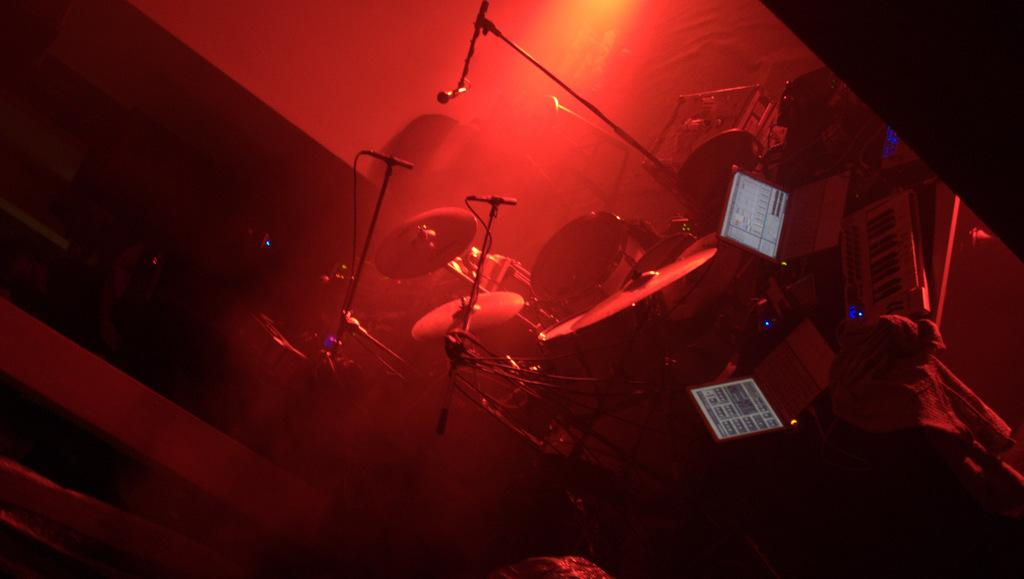What musical instruments are in the middle of the image? There are drums and a keyboard in the middle of the image. What electronic device is in the middle of the image? There is a laptop in the middle of the image. What is used for amplifying sound in the image? There is a microphone in the middle of the image. What can be seen behind the instruments in the image? There is a wall behind the instruments in the image. What type of question is being asked in the image? There is no question being asked in the image; it features musical instruments, a keyboard, a microphone, a laptop, and a wall. What is the source of steam in the image? There is no steam present in the image. 